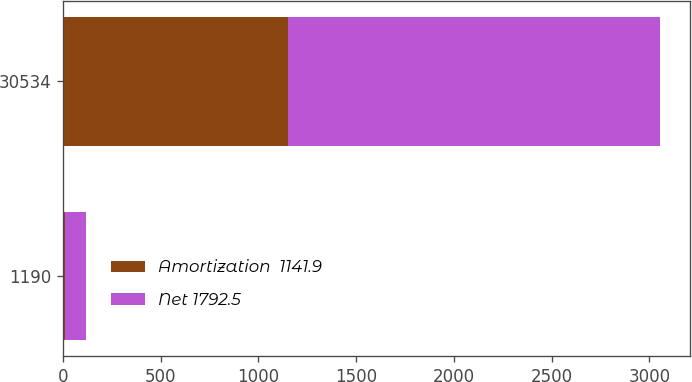Convert chart. <chart><loc_0><loc_0><loc_500><loc_500><stacked_bar_chart><ecel><fcel>1190<fcel>30534<nl><fcel>Amortization  1141.9<fcel>8.2<fcel>1150.1<nl><fcel>Net 1792.5<fcel>110.8<fcel>1903.3<nl></chart> 